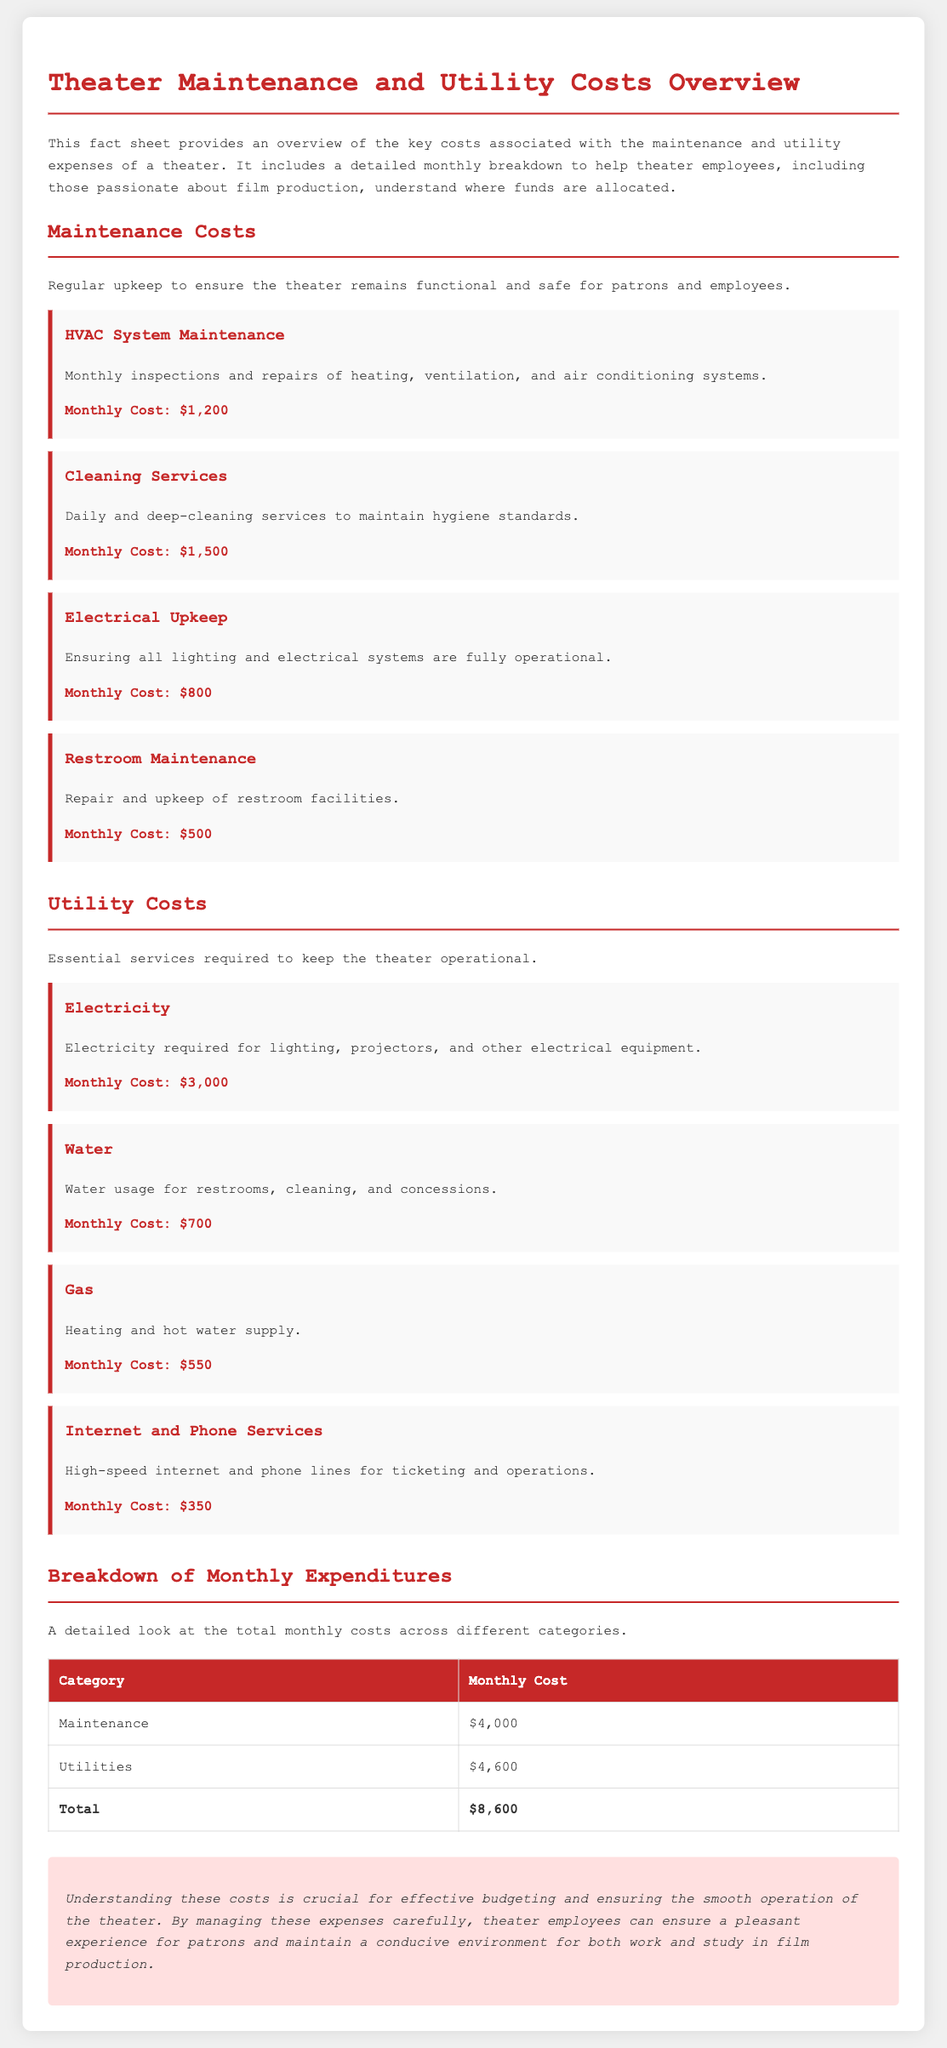what is the monthly cost of HVAC system maintenance? The document specifies that the monthly cost for HVAC system maintenance is $1,200.
Answer: $1,200 how much is spent monthly on cleaning services? The monthly expenditure for cleaning services is mentioned as $1,500 in the document.
Answer: $1,500 what is the total monthly expenditure for utilities? According to the breakdown in the document, the total monthly cost for utilities is $4,600.
Answer: $4,600 which utility cost is the highest? The document states that the highest utility cost is electricity, which costs $3,000 per month.
Answer: Electricity how much does restroom maintenance cost monthly? The document indicates that restroom maintenance costs $500 each month.
Answer: $500 what is the total monthly cost for maintenance and utilities combined? The total combined cost is calculated from the maintenance and utilities sections in the document, totaling $8,600.
Answer: $8,600 what maintenance category has the lowest monthly cost? The lowest maintenance cost is for restroom maintenance, which is $500 monthly.
Answer: Restroom Maintenance what does the conclusion emphasize regarding costs? The conclusion emphasizes the importance of understanding these costs for effective budgeting and smooth operation of the theater.
Answer: Effective budgeting what month does this fact sheet overview cover? The document doesn't specify a particular month but provides a general monthly breakdown for costs.
Answer: Not specified 